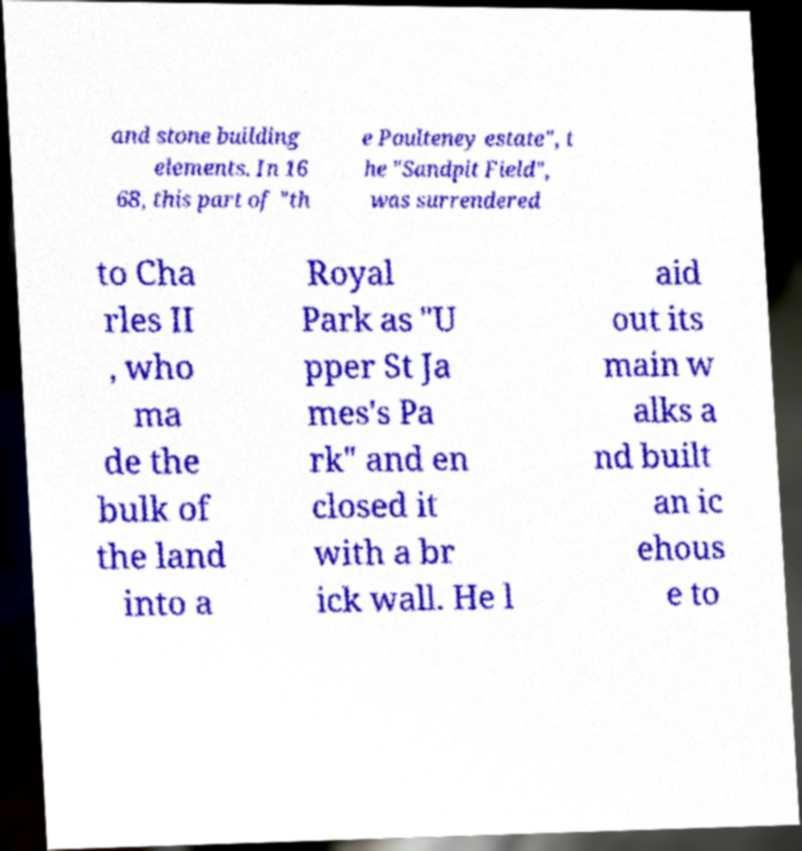Please identify and transcribe the text found in this image. and stone building elements. In 16 68, this part of "th e Poulteney estate", t he "Sandpit Field", was surrendered to Cha rles II , who ma de the bulk of the land into a Royal Park as "U pper St Ja mes's Pa rk" and en closed it with a br ick wall. He l aid out its main w alks a nd built an ic ehous e to 